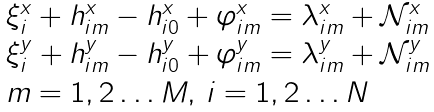Convert formula to latex. <formula><loc_0><loc_0><loc_500><loc_500>\begin{array} { l } { \xi } _ { i } ^ { x } + h _ { i m } ^ { x } - h _ { i 0 } ^ { x } + \varphi _ { i m } ^ { x } = \lambda _ { i m } ^ { x } + { \mathcal { N } } _ { i m } ^ { x } \\ { \xi } _ { i } ^ { y } + h _ { i m } ^ { y } - h _ { i 0 } ^ { y } + \varphi _ { i m } ^ { y } = \lambda _ { i m } ^ { y } + { \mathcal { N } } _ { i m } ^ { y } \\ m = 1 , 2 \dots M , \, i = 1 , 2 \dots N \end{array}</formula> 